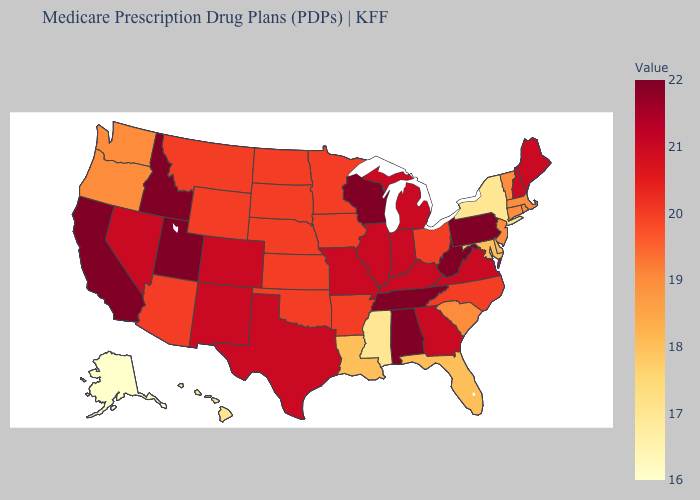Which states hav the highest value in the MidWest?
Give a very brief answer. Wisconsin. Which states have the lowest value in the Northeast?
Keep it brief. New York. Does Delaware have the highest value in the South?
Keep it brief. No. Does Louisiana have a lower value than Alaska?
Answer briefly. No. Which states have the lowest value in the MidWest?
Keep it brief. Iowa, Kansas, Minnesota, North Dakota, Nebraska, Ohio, South Dakota. 